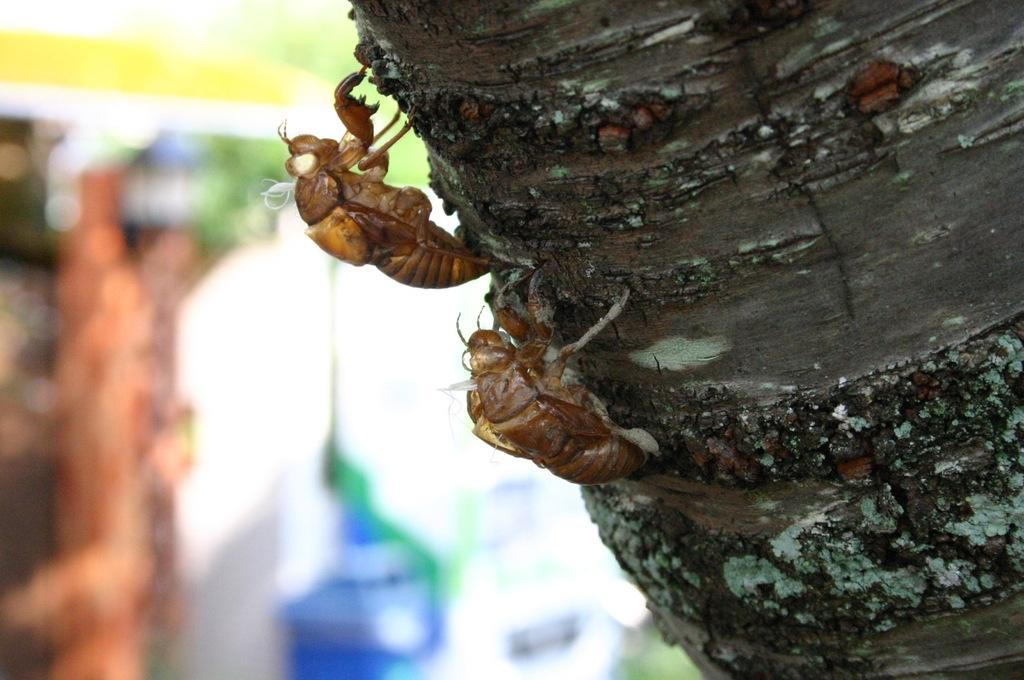What insects can be seen in the image? There are two bees in the image. Where are the bees located? The bees are standing on a stem. What can be observed about the background of the image? The background of the image is blurry. What type of needle is being used by the committee in the image? There is no committee or needle present in the image; it features two bees standing on a stem. Can you tell me how many firemen are visible in the image? There are no firemen present in the image. 